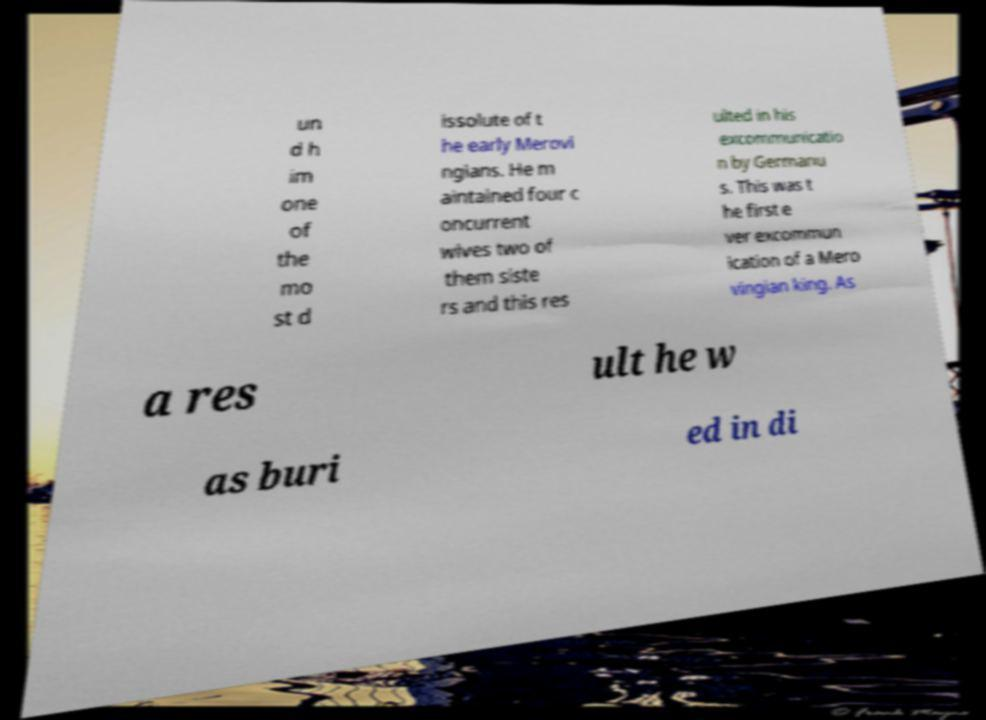For documentation purposes, I need the text within this image transcribed. Could you provide that? un d h im one of the mo st d issolute of t he early Merovi ngians. He m aintained four c oncurrent wives two of them siste rs and this res ulted in his excommunicatio n by Germanu s. This was t he first e ver excommun ication of a Mero vingian king. As a res ult he w as buri ed in di 